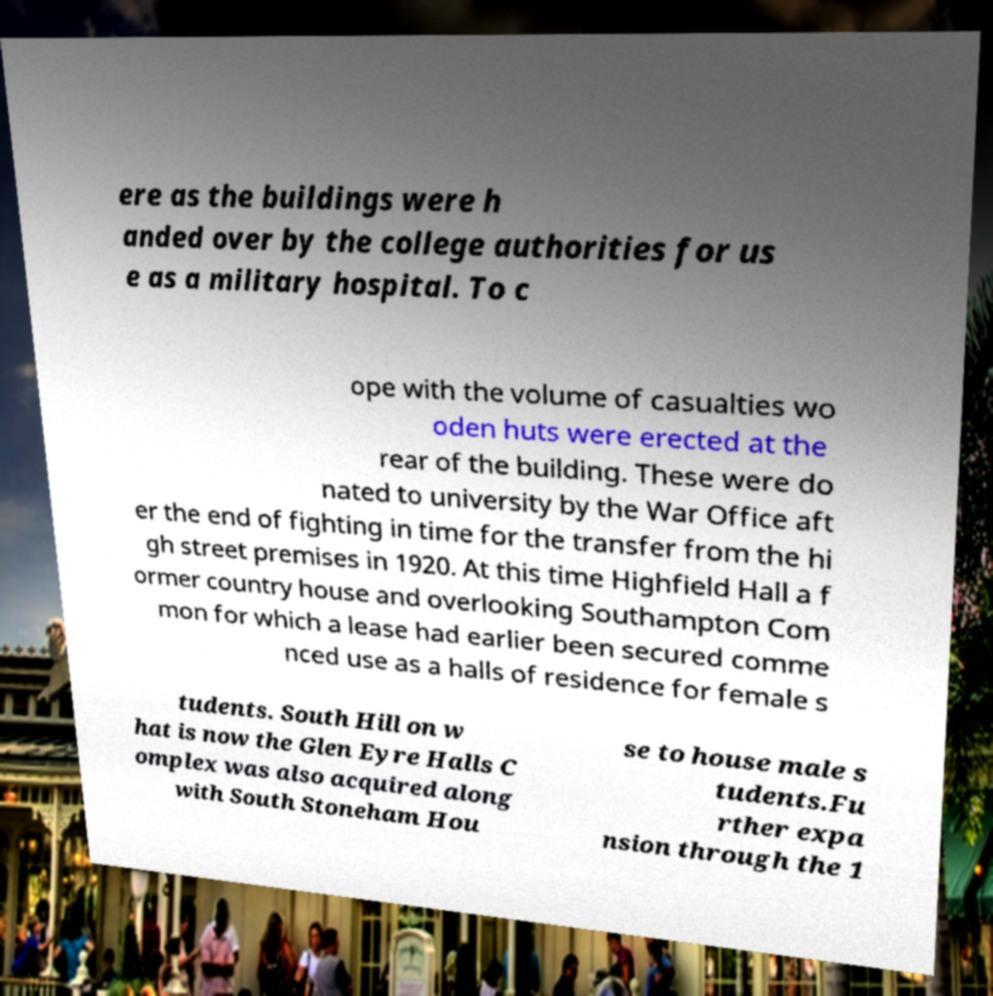Please identify and transcribe the text found in this image. ere as the buildings were h anded over by the college authorities for us e as a military hospital. To c ope with the volume of casualties wo oden huts were erected at the rear of the building. These were do nated to university by the War Office aft er the end of fighting in time for the transfer from the hi gh street premises in 1920. At this time Highfield Hall a f ormer country house and overlooking Southampton Com mon for which a lease had earlier been secured comme nced use as a halls of residence for female s tudents. South Hill on w hat is now the Glen Eyre Halls C omplex was also acquired along with South Stoneham Hou se to house male s tudents.Fu rther expa nsion through the 1 